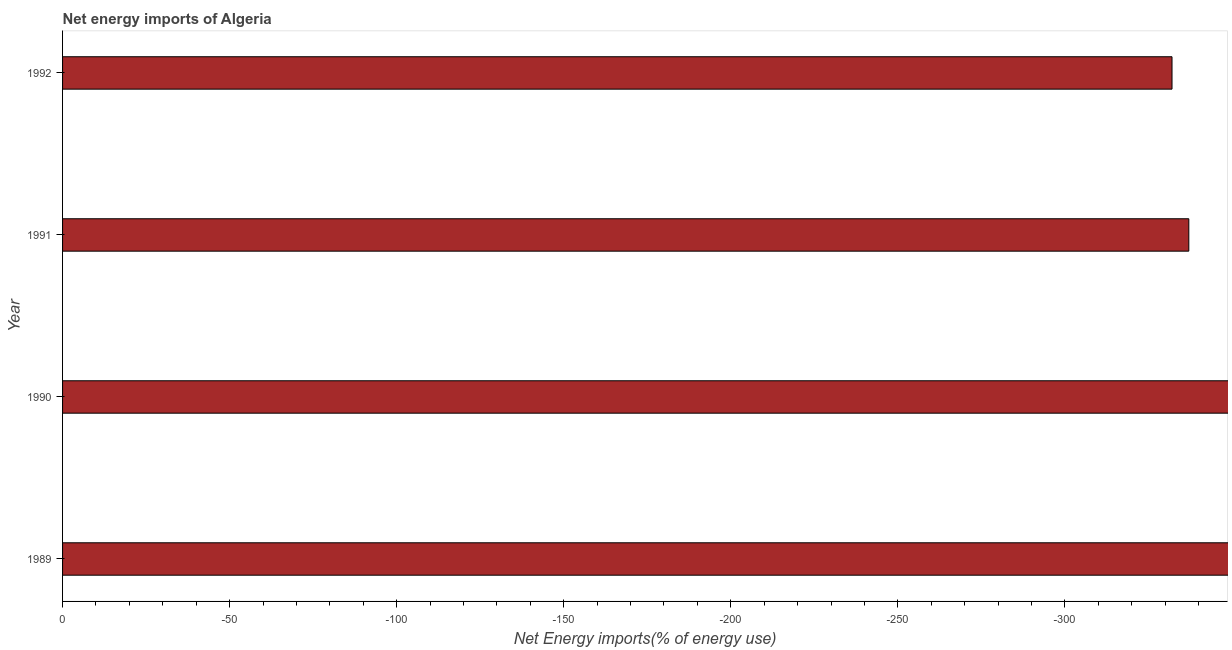Does the graph contain any zero values?
Provide a short and direct response. Yes. Does the graph contain grids?
Provide a succinct answer. No. What is the title of the graph?
Make the answer very short. Net energy imports of Algeria. What is the label or title of the X-axis?
Ensure brevity in your answer.  Net Energy imports(% of energy use). What is the energy imports in 1992?
Your response must be concise. 0. Across all years, what is the minimum energy imports?
Keep it short and to the point. 0. What is the average energy imports per year?
Ensure brevity in your answer.  0. What is the median energy imports?
Your answer should be very brief. 0. In how many years, is the energy imports greater than -170 %?
Ensure brevity in your answer.  0. How many bars are there?
Offer a very short reply. 0. What is the difference between two consecutive major ticks on the X-axis?
Provide a succinct answer. 50. What is the Net Energy imports(% of energy use) of 1990?
Your answer should be compact. 0. What is the Net Energy imports(% of energy use) in 1991?
Provide a short and direct response. 0. What is the Net Energy imports(% of energy use) in 1992?
Offer a very short reply. 0. 